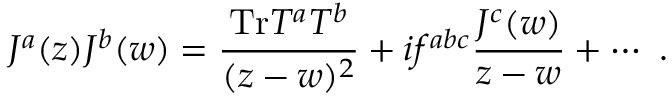Convert formula to latex. <formula><loc_0><loc_0><loc_500><loc_500>J ^ { a } ( z ) J ^ { b } ( w ) = \frac { T r T ^ { a } T ^ { b } } { ( z - w ) ^ { 2 } } + i f ^ { a b c } \frac { J ^ { c } ( w ) } { z - w } + \cdots .</formula> 